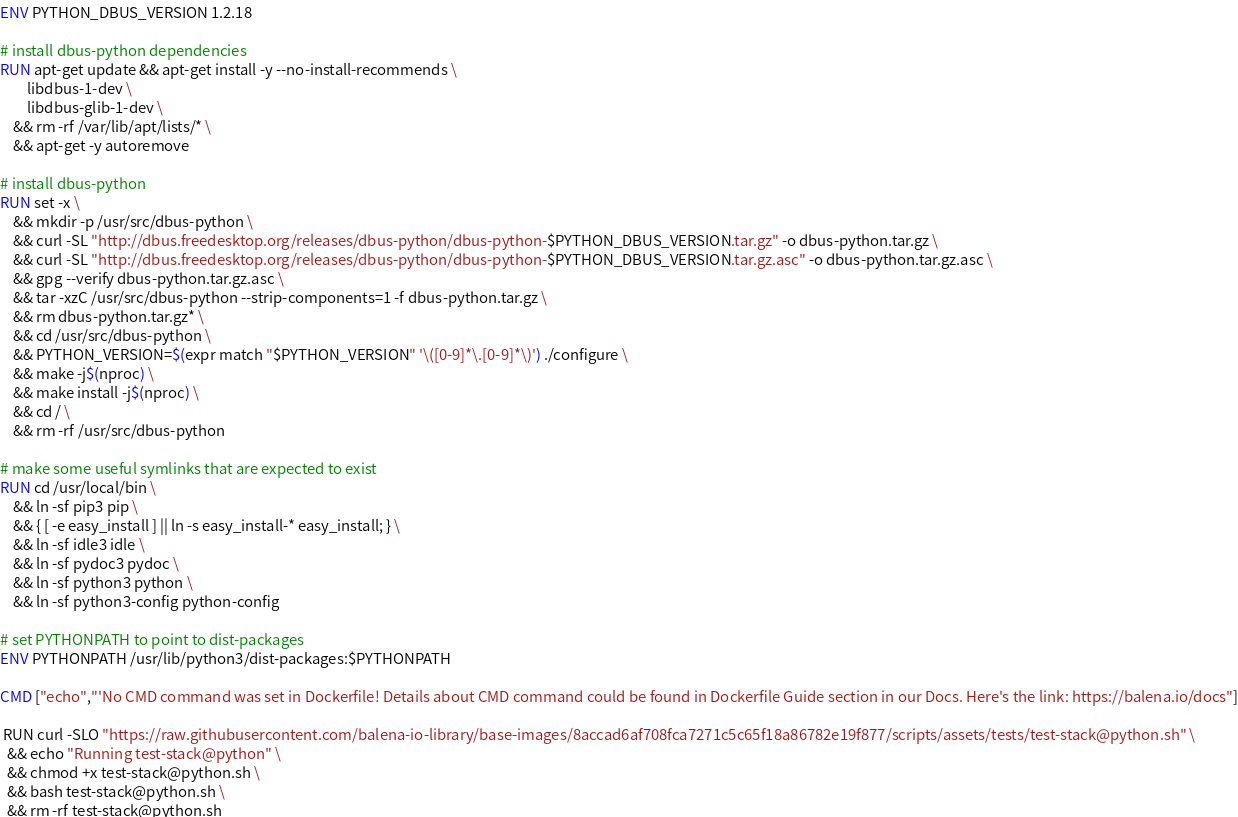<code> <loc_0><loc_0><loc_500><loc_500><_Dockerfile_>ENV PYTHON_DBUS_VERSION 1.2.18

# install dbus-python dependencies 
RUN apt-get update && apt-get install -y --no-install-recommends \
		libdbus-1-dev \
		libdbus-glib-1-dev \
	&& rm -rf /var/lib/apt/lists/* \
	&& apt-get -y autoremove

# install dbus-python
RUN set -x \
	&& mkdir -p /usr/src/dbus-python \
	&& curl -SL "http://dbus.freedesktop.org/releases/dbus-python/dbus-python-$PYTHON_DBUS_VERSION.tar.gz" -o dbus-python.tar.gz \
	&& curl -SL "http://dbus.freedesktop.org/releases/dbus-python/dbus-python-$PYTHON_DBUS_VERSION.tar.gz.asc" -o dbus-python.tar.gz.asc \
	&& gpg --verify dbus-python.tar.gz.asc \
	&& tar -xzC /usr/src/dbus-python --strip-components=1 -f dbus-python.tar.gz \
	&& rm dbus-python.tar.gz* \
	&& cd /usr/src/dbus-python \
	&& PYTHON_VERSION=$(expr match "$PYTHON_VERSION" '\([0-9]*\.[0-9]*\)') ./configure \
	&& make -j$(nproc) \
	&& make install -j$(nproc) \
	&& cd / \
	&& rm -rf /usr/src/dbus-python

# make some useful symlinks that are expected to exist
RUN cd /usr/local/bin \
	&& ln -sf pip3 pip \
	&& { [ -e easy_install ] || ln -s easy_install-* easy_install; } \
	&& ln -sf idle3 idle \
	&& ln -sf pydoc3 pydoc \
	&& ln -sf python3 python \
	&& ln -sf python3-config python-config

# set PYTHONPATH to point to dist-packages
ENV PYTHONPATH /usr/lib/python3/dist-packages:$PYTHONPATH

CMD ["echo","'No CMD command was set in Dockerfile! Details about CMD command could be found in Dockerfile Guide section in our Docs. Here's the link: https://balena.io/docs"]

 RUN curl -SLO "https://raw.githubusercontent.com/balena-io-library/base-images/8accad6af708fca7271c5c65f18a86782e19f877/scripts/assets/tests/test-stack@python.sh" \
  && echo "Running test-stack@python" \
  && chmod +x test-stack@python.sh \
  && bash test-stack@python.sh \
  && rm -rf test-stack@python.sh 
</code> 